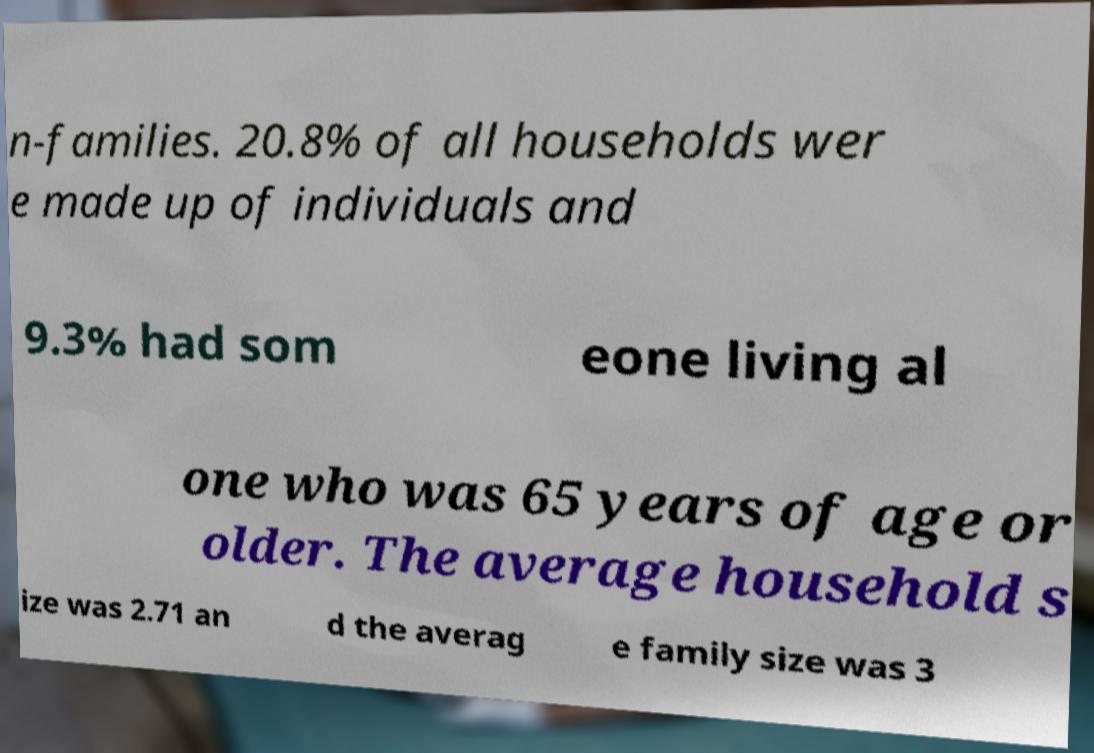I need the written content from this picture converted into text. Can you do that? n-families. 20.8% of all households wer e made up of individuals and 9.3% had som eone living al one who was 65 years of age or older. The average household s ize was 2.71 an d the averag e family size was 3 